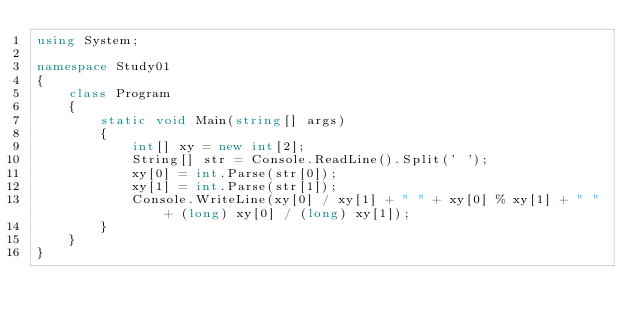<code> <loc_0><loc_0><loc_500><loc_500><_C#_>using System;

namespace Study01
{
    class Program
    {
        static void Main(string[] args)
        {
            int[] xy = new int[2];
            String[] str = Console.ReadLine().Split(' ');
            xy[0] = int.Parse(str[0]);
            xy[1] = int.Parse(str[1]);
            Console.WriteLine(xy[0] / xy[1] + " " + xy[0] % xy[1] + " " + (long) xy[0] / (long) xy[1]);
        }
    }
}</code> 